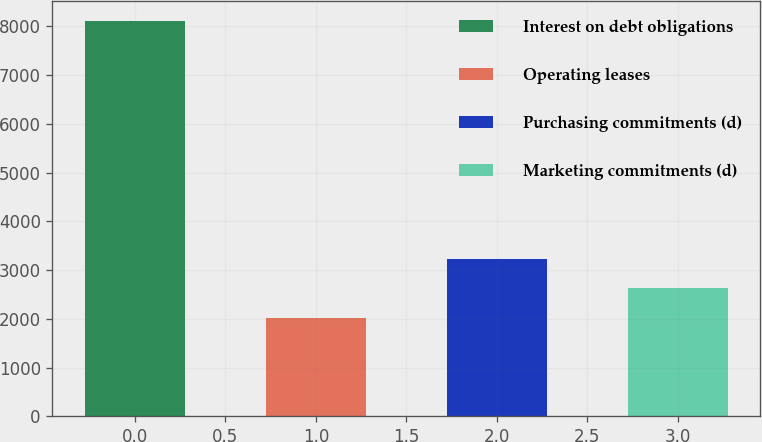Convert chart. <chart><loc_0><loc_0><loc_500><loc_500><bar_chart><fcel>Interest on debt obligations<fcel>Operating leases<fcel>Purchasing commitments (d)<fcel>Marketing commitments (d)<nl><fcel>8107<fcel>2014<fcel>3232.6<fcel>2623.3<nl></chart> 